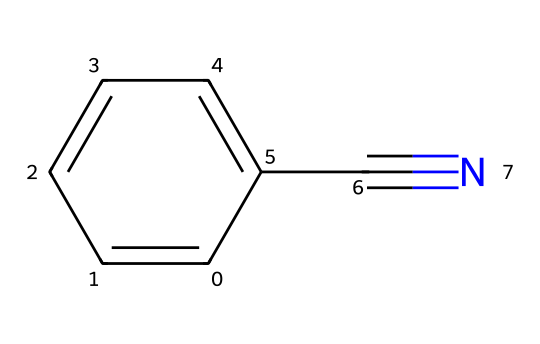How many carbon atoms are in benzonitrile? The SMILES representation contains six carbon atoms in the benzene ring (c1ccccc1) and one additional carbon in the nitrile group (C#N). Therefore, the total number of carbon atoms is seven.
Answer: seven What type of functional group is present in benzonitrile? The presence of the nitrile group (C#N) in the SMILES indicates that the chemical has a nitrile functional group, which is characterized by a carbon triple-bonded to a nitrogen atom.
Answer: nitrile How many hydrogen atoms are in benzonitrile? The benzene ring has five hydrogens (as one hydrogen is replaced by the nitrile group), thus in total there are five hydrogen atoms in benzonitrile.
Answer: five What is the visual appearance of the nitrile group in benzonitrile? The nitrile group in the chemical structure appears as C#N, where the carbon is triple-bonded to the nitrogen, indicating a straight arrangement with high bond strength.
Answer: C#N Is benzonitrile polar or non-polar? The presence of the highly electronegative nitrogen atom in the nitrile group contributes to a polar character, while the benzene ring's symmetrical structure tends to be non-polar. However, the overall structure is moderately polar due to the nitrile functional group influence.
Answer: polar What is the hybridization of the carbon atom in the nitrile group of benzonitrile? The carbon atom in the nitrile group is sp hybridized as it forms a triple bond with nitrogen, which requires two p orbitals and one s orbital for its hybridization.
Answer: sp Why is benzonitrile considered a valuable solvent in the art sector? Benzonitrile is an organic solvent with a relatively low boiling point and good solvency properties for various organic materials, making it effective for cleaning purposes in art supplies.
Answer: effective solvent 